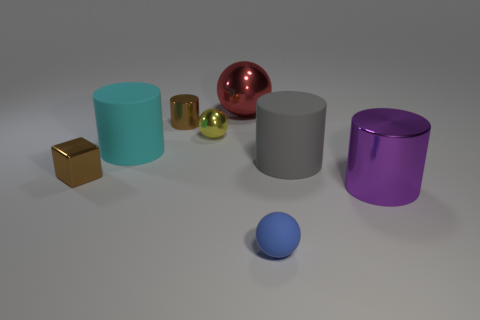Subtract all green cylinders. Subtract all green balls. How many cylinders are left? 4 Add 1 small blue things. How many objects exist? 9 Subtract all blocks. How many objects are left? 7 Add 6 blue rubber spheres. How many blue rubber spheres are left? 7 Add 2 blocks. How many blocks exist? 3 Subtract 0 brown balls. How many objects are left? 8 Subtract all red balls. Subtract all tiny blue spheres. How many objects are left? 6 